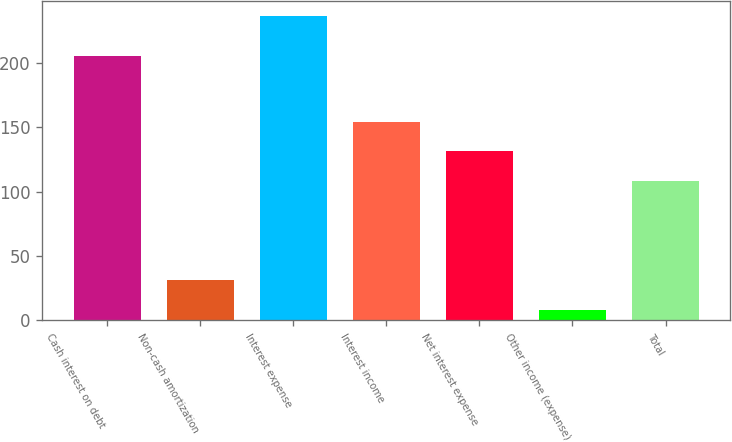Convert chart to OTSL. <chart><loc_0><loc_0><loc_500><loc_500><bar_chart><fcel>Cash interest on debt<fcel>Non-cash amortization<fcel>Interest expense<fcel>Interest income<fcel>Net interest expense<fcel>Other income (expense)<fcel>Total<nl><fcel>205.9<fcel>31.32<fcel>236.7<fcel>154.24<fcel>131.42<fcel>8.5<fcel>108.6<nl></chart> 